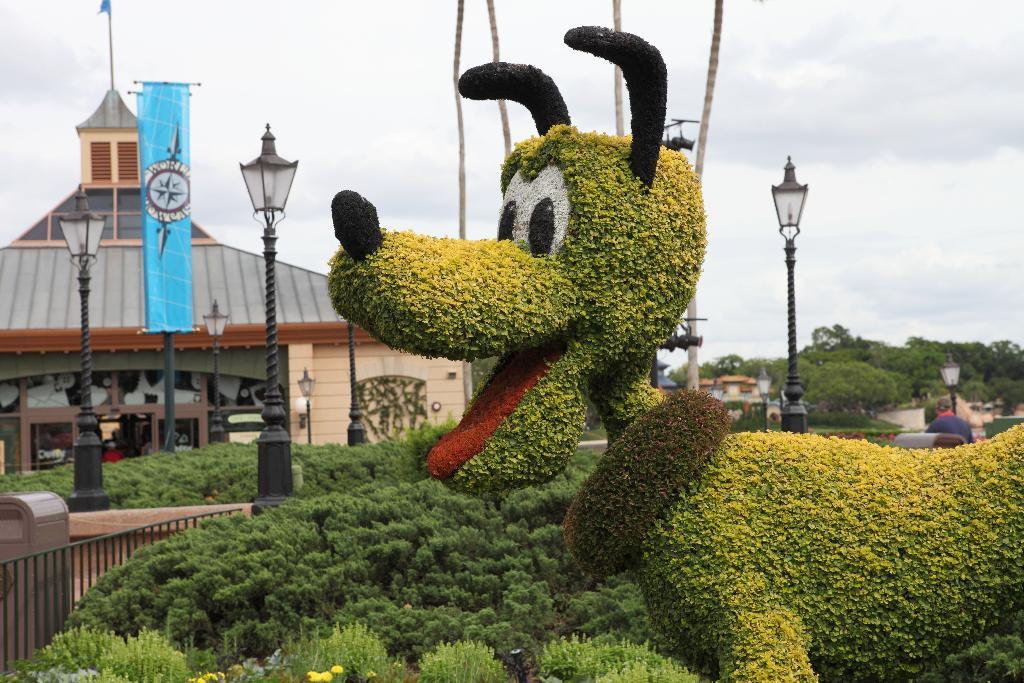What type of statue is on the right side of the image? There is a grass statue on the right side of the image. What is located at the bottom of the image? There are bushes at the bottom of the image. What can be seen in the background of the image? There are poles, at least one building, ropes, the sky, and trees in the background of the image. What type of bird can be seen perched on the grass statue in the image? There are no birds visible in the image, including robins. 